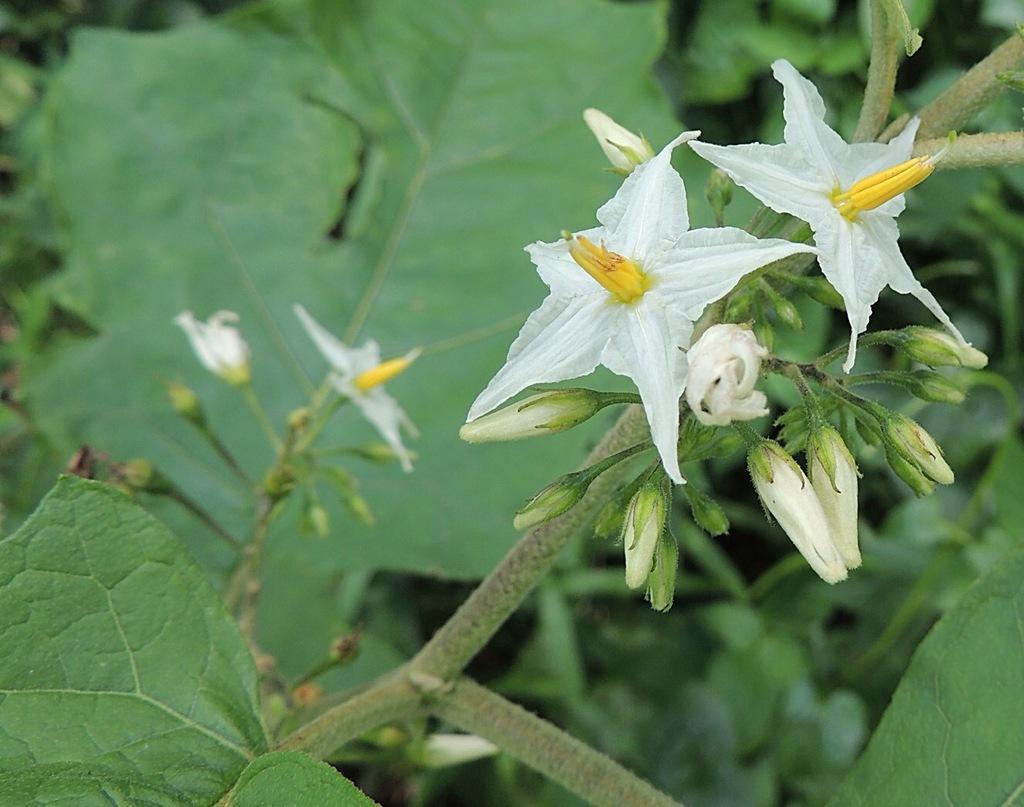How would you summarize this image in a sentence or two? In this picture I can see few white color flowers and few buds. In the background I can see the leaves on the stems. 